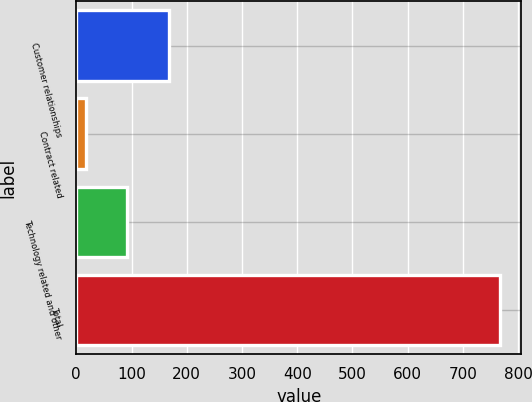Convert chart to OTSL. <chart><loc_0><loc_0><loc_500><loc_500><bar_chart><fcel>Customer relationships<fcel>Contract related<fcel>Technology related and other<fcel>Total<nl><fcel>167<fcel>17<fcel>92<fcel>767<nl></chart> 